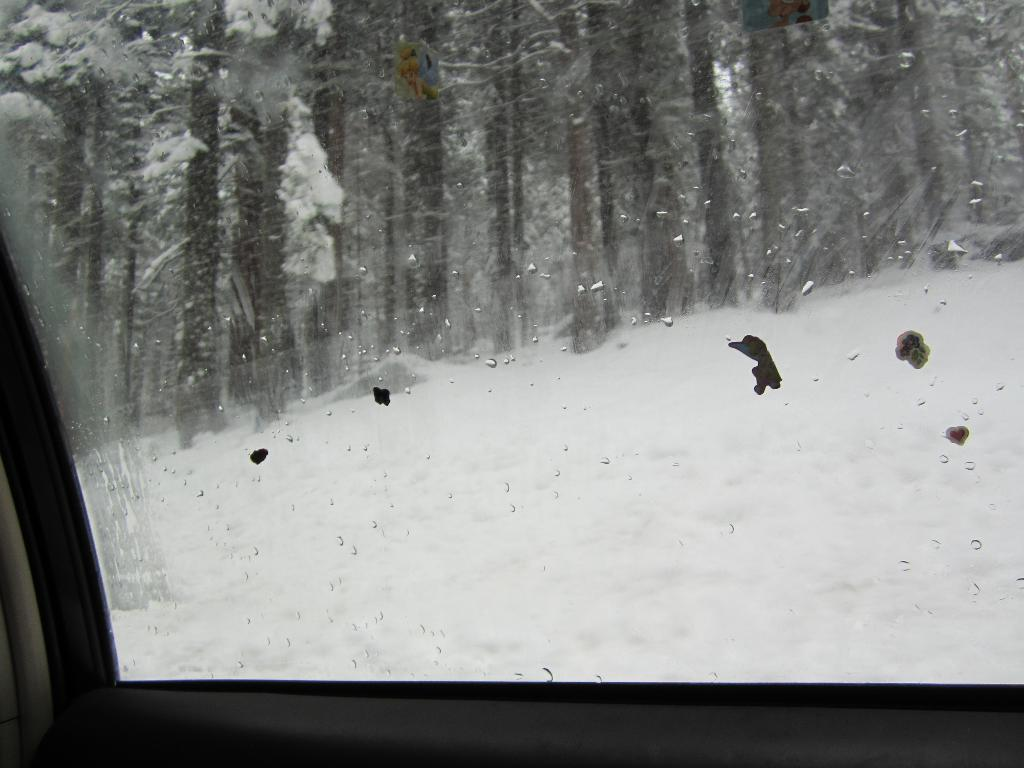What material is present in the image? The image contains glass. What can be seen through the glass in the image? Snow and trees are visible through the glass. What is the name of the son who works at the mine in the image? There is no son or mine present in the image. 